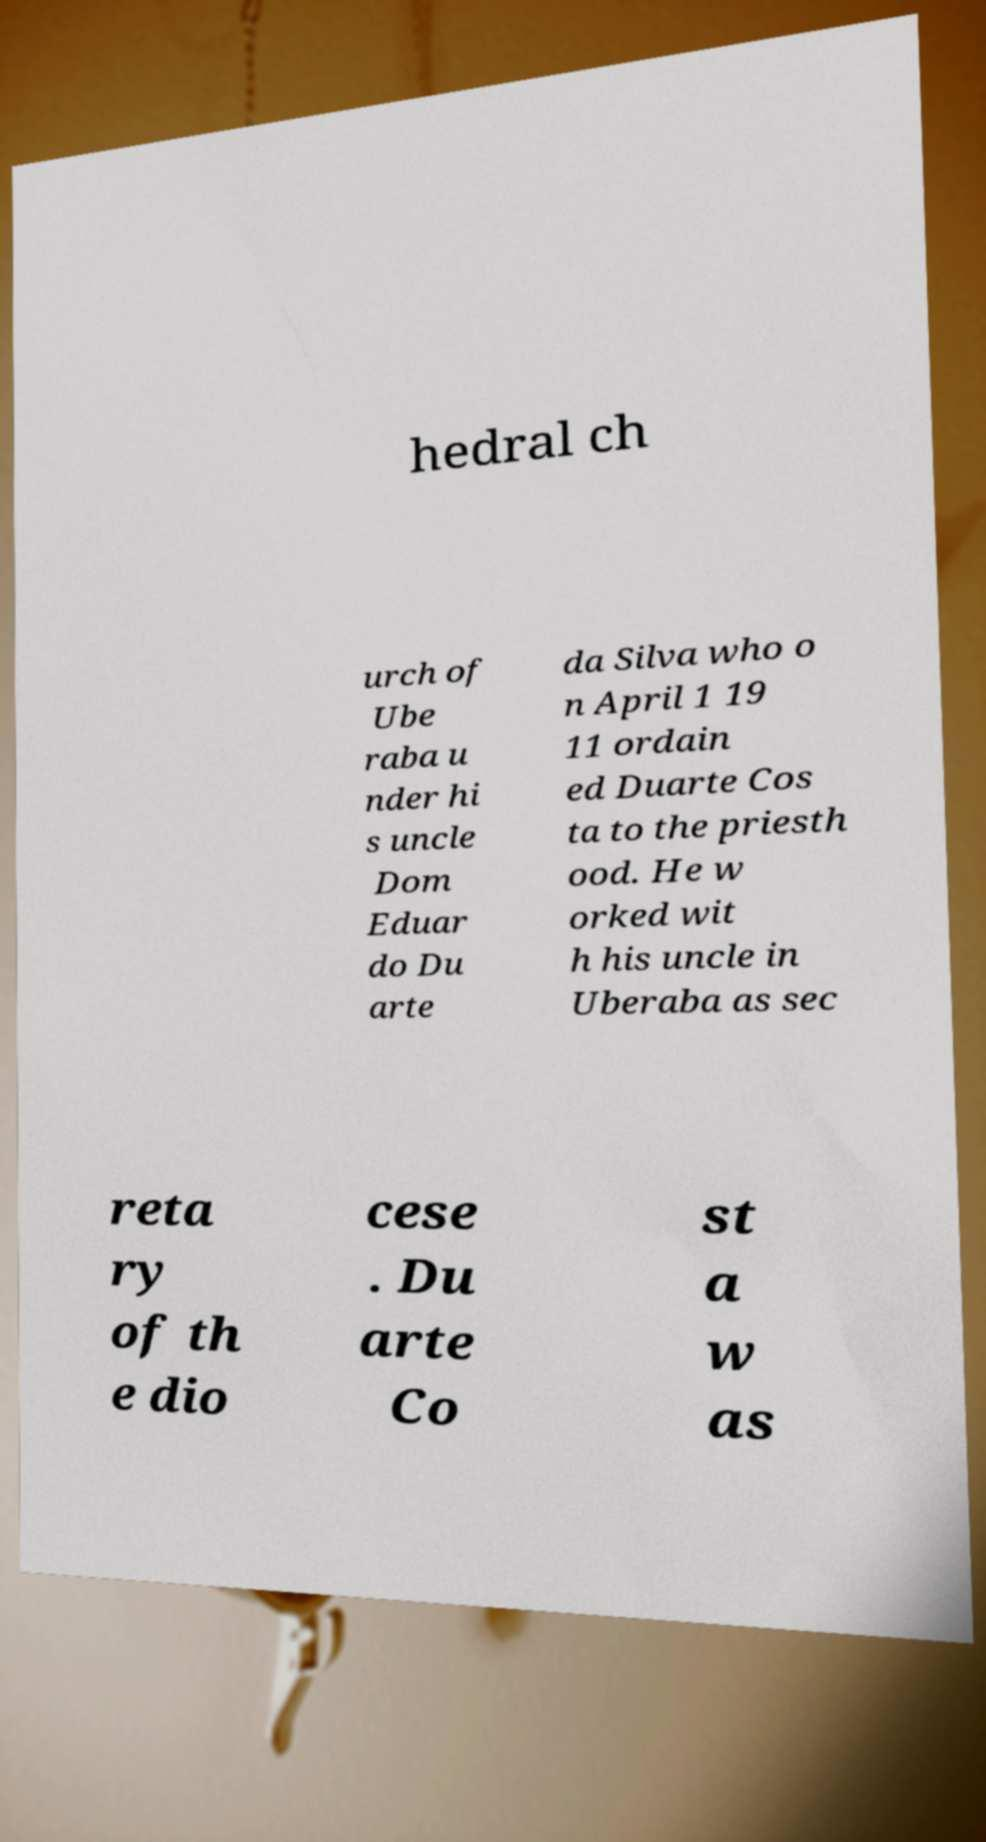Could you extract and type out the text from this image? hedral ch urch of Ube raba u nder hi s uncle Dom Eduar do Du arte da Silva who o n April 1 19 11 ordain ed Duarte Cos ta to the priesth ood. He w orked wit h his uncle in Uberaba as sec reta ry of th e dio cese . Du arte Co st a w as 